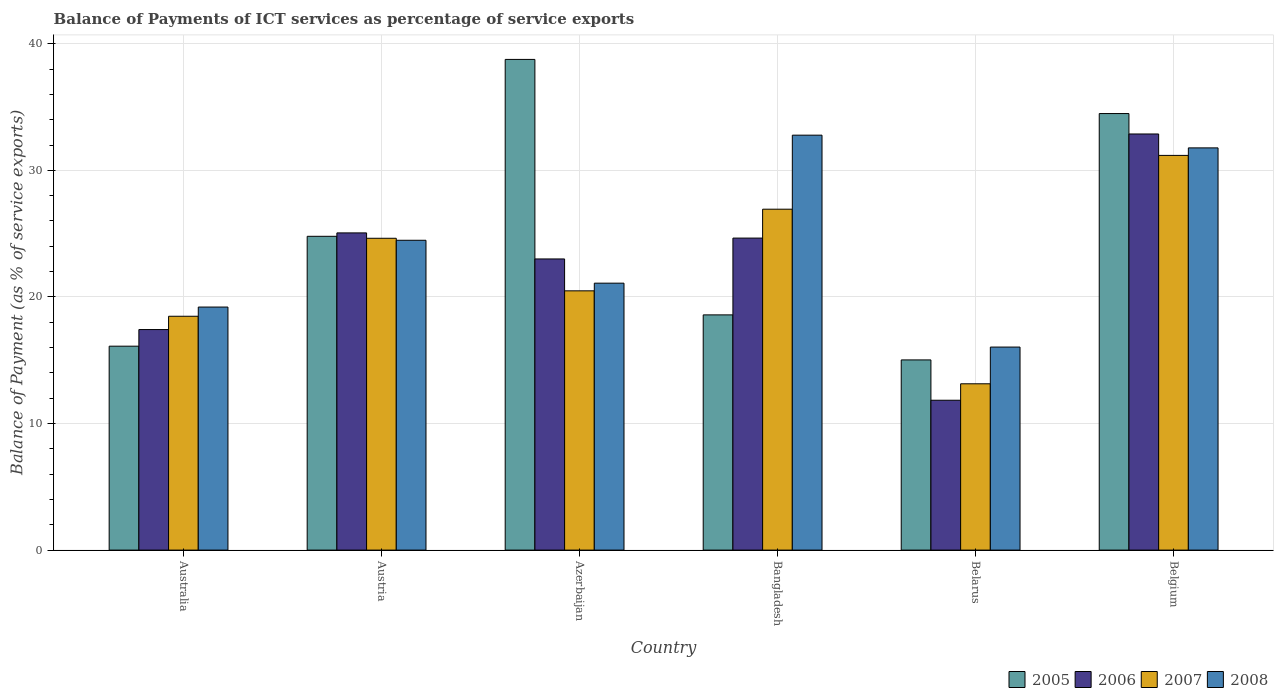Are the number of bars on each tick of the X-axis equal?
Ensure brevity in your answer.  Yes. How many bars are there on the 3rd tick from the left?
Make the answer very short. 4. What is the label of the 4th group of bars from the left?
Your response must be concise. Bangladesh. In how many cases, is the number of bars for a given country not equal to the number of legend labels?
Offer a terse response. 0. What is the balance of payments of ICT services in 2008 in Australia?
Give a very brief answer. 19.2. Across all countries, what is the maximum balance of payments of ICT services in 2008?
Provide a succinct answer. 32.78. Across all countries, what is the minimum balance of payments of ICT services in 2006?
Provide a short and direct response. 11.84. In which country was the balance of payments of ICT services in 2006 maximum?
Give a very brief answer. Belgium. In which country was the balance of payments of ICT services in 2008 minimum?
Ensure brevity in your answer.  Belarus. What is the total balance of payments of ICT services in 2006 in the graph?
Offer a terse response. 134.83. What is the difference between the balance of payments of ICT services in 2007 in Australia and that in Belarus?
Keep it short and to the point. 5.33. What is the difference between the balance of payments of ICT services in 2006 in Belgium and the balance of payments of ICT services in 2008 in Australia?
Ensure brevity in your answer.  13.67. What is the average balance of payments of ICT services in 2007 per country?
Ensure brevity in your answer.  22.47. What is the difference between the balance of payments of ICT services of/in 2008 and balance of payments of ICT services of/in 2005 in Australia?
Your response must be concise. 3.09. In how many countries, is the balance of payments of ICT services in 2008 greater than 16 %?
Make the answer very short. 6. What is the ratio of the balance of payments of ICT services in 2007 in Australia to that in Bangladesh?
Your answer should be very brief. 0.69. What is the difference between the highest and the second highest balance of payments of ICT services in 2006?
Offer a terse response. 7.81. What is the difference between the highest and the lowest balance of payments of ICT services in 2007?
Ensure brevity in your answer.  18.04. Is the sum of the balance of payments of ICT services in 2007 in Azerbaijan and Belarus greater than the maximum balance of payments of ICT services in 2005 across all countries?
Give a very brief answer. No. Is it the case that in every country, the sum of the balance of payments of ICT services in 2005 and balance of payments of ICT services in 2007 is greater than the sum of balance of payments of ICT services in 2008 and balance of payments of ICT services in 2006?
Offer a very short reply. No. What does the 1st bar from the left in Belarus represents?
Offer a very short reply. 2005. Is it the case that in every country, the sum of the balance of payments of ICT services in 2007 and balance of payments of ICT services in 2005 is greater than the balance of payments of ICT services in 2008?
Make the answer very short. Yes. How many bars are there?
Your response must be concise. 24. Are all the bars in the graph horizontal?
Make the answer very short. No. What is the difference between two consecutive major ticks on the Y-axis?
Offer a very short reply. 10. Are the values on the major ticks of Y-axis written in scientific E-notation?
Your response must be concise. No. Does the graph contain any zero values?
Ensure brevity in your answer.  No. Does the graph contain grids?
Keep it short and to the point. Yes. How many legend labels are there?
Offer a very short reply. 4. What is the title of the graph?
Your answer should be very brief. Balance of Payments of ICT services as percentage of service exports. What is the label or title of the Y-axis?
Your answer should be compact. Balance of Payment (as % of service exports). What is the Balance of Payment (as % of service exports) of 2005 in Australia?
Your answer should be very brief. 16.11. What is the Balance of Payment (as % of service exports) in 2006 in Australia?
Your answer should be compact. 17.42. What is the Balance of Payment (as % of service exports) in 2007 in Australia?
Offer a terse response. 18.47. What is the Balance of Payment (as % of service exports) of 2008 in Australia?
Give a very brief answer. 19.2. What is the Balance of Payment (as % of service exports) in 2005 in Austria?
Your response must be concise. 24.79. What is the Balance of Payment (as % of service exports) of 2006 in Austria?
Provide a succinct answer. 25.06. What is the Balance of Payment (as % of service exports) of 2007 in Austria?
Offer a terse response. 24.63. What is the Balance of Payment (as % of service exports) in 2008 in Austria?
Provide a succinct answer. 24.47. What is the Balance of Payment (as % of service exports) of 2005 in Azerbaijan?
Your response must be concise. 38.76. What is the Balance of Payment (as % of service exports) of 2006 in Azerbaijan?
Your answer should be compact. 23. What is the Balance of Payment (as % of service exports) in 2007 in Azerbaijan?
Your response must be concise. 20.48. What is the Balance of Payment (as % of service exports) of 2008 in Azerbaijan?
Give a very brief answer. 21.09. What is the Balance of Payment (as % of service exports) of 2005 in Bangladesh?
Make the answer very short. 18.58. What is the Balance of Payment (as % of service exports) in 2006 in Bangladesh?
Give a very brief answer. 24.65. What is the Balance of Payment (as % of service exports) of 2007 in Bangladesh?
Provide a short and direct response. 26.93. What is the Balance of Payment (as % of service exports) in 2008 in Bangladesh?
Make the answer very short. 32.78. What is the Balance of Payment (as % of service exports) of 2005 in Belarus?
Keep it short and to the point. 15.02. What is the Balance of Payment (as % of service exports) of 2006 in Belarus?
Offer a terse response. 11.84. What is the Balance of Payment (as % of service exports) of 2007 in Belarus?
Your answer should be compact. 13.14. What is the Balance of Payment (as % of service exports) of 2008 in Belarus?
Provide a succinct answer. 16.04. What is the Balance of Payment (as % of service exports) in 2005 in Belgium?
Provide a short and direct response. 34.48. What is the Balance of Payment (as % of service exports) of 2006 in Belgium?
Your response must be concise. 32.87. What is the Balance of Payment (as % of service exports) of 2007 in Belgium?
Offer a terse response. 31.18. What is the Balance of Payment (as % of service exports) in 2008 in Belgium?
Give a very brief answer. 31.77. Across all countries, what is the maximum Balance of Payment (as % of service exports) in 2005?
Make the answer very short. 38.76. Across all countries, what is the maximum Balance of Payment (as % of service exports) in 2006?
Your answer should be compact. 32.87. Across all countries, what is the maximum Balance of Payment (as % of service exports) in 2007?
Your response must be concise. 31.18. Across all countries, what is the maximum Balance of Payment (as % of service exports) in 2008?
Your answer should be very brief. 32.78. Across all countries, what is the minimum Balance of Payment (as % of service exports) of 2005?
Offer a terse response. 15.02. Across all countries, what is the minimum Balance of Payment (as % of service exports) of 2006?
Give a very brief answer. 11.84. Across all countries, what is the minimum Balance of Payment (as % of service exports) of 2007?
Offer a terse response. 13.14. Across all countries, what is the minimum Balance of Payment (as % of service exports) in 2008?
Keep it short and to the point. 16.04. What is the total Balance of Payment (as % of service exports) of 2005 in the graph?
Keep it short and to the point. 147.75. What is the total Balance of Payment (as % of service exports) in 2006 in the graph?
Provide a succinct answer. 134.83. What is the total Balance of Payment (as % of service exports) in 2007 in the graph?
Offer a terse response. 134.83. What is the total Balance of Payment (as % of service exports) in 2008 in the graph?
Give a very brief answer. 145.35. What is the difference between the Balance of Payment (as % of service exports) in 2005 in Australia and that in Austria?
Your answer should be compact. -8.68. What is the difference between the Balance of Payment (as % of service exports) in 2006 in Australia and that in Austria?
Make the answer very short. -7.63. What is the difference between the Balance of Payment (as % of service exports) of 2007 in Australia and that in Austria?
Give a very brief answer. -6.16. What is the difference between the Balance of Payment (as % of service exports) of 2008 in Australia and that in Austria?
Offer a very short reply. -5.28. What is the difference between the Balance of Payment (as % of service exports) in 2005 in Australia and that in Azerbaijan?
Your answer should be compact. -22.65. What is the difference between the Balance of Payment (as % of service exports) in 2006 in Australia and that in Azerbaijan?
Offer a very short reply. -5.58. What is the difference between the Balance of Payment (as % of service exports) of 2007 in Australia and that in Azerbaijan?
Offer a terse response. -2.01. What is the difference between the Balance of Payment (as % of service exports) in 2008 in Australia and that in Azerbaijan?
Ensure brevity in your answer.  -1.89. What is the difference between the Balance of Payment (as % of service exports) of 2005 in Australia and that in Bangladesh?
Provide a succinct answer. -2.47. What is the difference between the Balance of Payment (as % of service exports) in 2006 in Australia and that in Bangladesh?
Give a very brief answer. -7.22. What is the difference between the Balance of Payment (as % of service exports) in 2007 in Australia and that in Bangladesh?
Ensure brevity in your answer.  -8.46. What is the difference between the Balance of Payment (as % of service exports) of 2008 in Australia and that in Bangladesh?
Offer a terse response. -13.58. What is the difference between the Balance of Payment (as % of service exports) in 2005 in Australia and that in Belarus?
Ensure brevity in your answer.  1.08. What is the difference between the Balance of Payment (as % of service exports) in 2006 in Australia and that in Belarus?
Offer a very short reply. 5.58. What is the difference between the Balance of Payment (as % of service exports) of 2007 in Australia and that in Belarus?
Offer a terse response. 5.33. What is the difference between the Balance of Payment (as % of service exports) of 2008 in Australia and that in Belarus?
Provide a succinct answer. 3.16. What is the difference between the Balance of Payment (as % of service exports) of 2005 in Australia and that in Belgium?
Your response must be concise. -18.38. What is the difference between the Balance of Payment (as % of service exports) in 2006 in Australia and that in Belgium?
Your answer should be very brief. -15.45. What is the difference between the Balance of Payment (as % of service exports) in 2007 in Australia and that in Belgium?
Offer a very short reply. -12.71. What is the difference between the Balance of Payment (as % of service exports) of 2008 in Australia and that in Belgium?
Offer a terse response. -12.57. What is the difference between the Balance of Payment (as % of service exports) of 2005 in Austria and that in Azerbaijan?
Keep it short and to the point. -13.97. What is the difference between the Balance of Payment (as % of service exports) of 2006 in Austria and that in Azerbaijan?
Give a very brief answer. 2.06. What is the difference between the Balance of Payment (as % of service exports) of 2007 in Austria and that in Azerbaijan?
Offer a very short reply. 4.15. What is the difference between the Balance of Payment (as % of service exports) in 2008 in Austria and that in Azerbaijan?
Ensure brevity in your answer.  3.39. What is the difference between the Balance of Payment (as % of service exports) of 2005 in Austria and that in Bangladesh?
Provide a succinct answer. 6.21. What is the difference between the Balance of Payment (as % of service exports) of 2006 in Austria and that in Bangladesh?
Provide a succinct answer. 0.41. What is the difference between the Balance of Payment (as % of service exports) of 2007 in Austria and that in Bangladesh?
Provide a short and direct response. -2.3. What is the difference between the Balance of Payment (as % of service exports) in 2008 in Austria and that in Bangladesh?
Offer a terse response. -8.3. What is the difference between the Balance of Payment (as % of service exports) in 2005 in Austria and that in Belarus?
Keep it short and to the point. 9.76. What is the difference between the Balance of Payment (as % of service exports) of 2006 in Austria and that in Belarus?
Your response must be concise. 13.22. What is the difference between the Balance of Payment (as % of service exports) in 2007 in Austria and that in Belarus?
Your answer should be compact. 11.5. What is the difference between the Balance of Payment (as % of service exports) in 2008 in Austria and that in Belarus?
Your response must be concise. 8.44. What is the difference between the Balance of Payment (as % of service exports) of 2005 in Austria and that in Belgium?
Provide a short and direct response. -9.7. What is the difference between the Balance of Payment (as % of service exports) of 2006 in Austria and that in Belgium?
Offer a very short reply. -7.81. What is the difference between the Balance of Payment (as % of service exports) of 2007 in Austria and that in Belgium?
Give a very brief answer. -6.55. What is the difference between the Balance of Payment (as % of service exports) of 2008 in Austria and that in Belgium?
Your answer should be compact. -7.3. What is the difference between the Balance of Payment (as % of service exports) in 2005 in Azerbaijan and that in Bangladesh?
Your response must be concise. 20.18. What is the difference between the Balance of Payment (as % of service exports) of 2006 in Azerbaijan and that in Bangladesh?
Your response must be concise. -1.65. What is the difference between the Balance of Payment (as % of service exports) of 2007 in Azerbaijan and that in Bangladesh?
Keep it short and to the point. -6.45. What is the difference between the Balance of Payment (as % of service exports) of 2008 in Azerbaijan and that in Bangladesh?
Your answer should be compact. -11.69. What is the difference between the Balance of Payment (as % of service exports) in 2005 in Azerbaijan and that in Belarus?
Keep it short and to the point. 23.74. What is the difference between the Balance of Payment (as % of service exports) in 2006 in Azerbaijan and that in Belarus?
Offer a terse response. 11.16. What is the difference between the Balance of Payment (as % of service exports) in 2007 in Azerbaijan and that in Belarus?
Keep it short and to the point. 7.34. What is the difference between the Balance of Payment (as % of service exports) in 2008 in Azerbaijan and that in Belarus?
Keep it short and to the point. 5.05. What is the difference between the Balance of Payment (as % of service exports) in 2005 in Azerbaijan and that in Belgium?
Your response must be concise. 4.28. What is the difference between the Balance of Payment (as % of service exports) in 2006 in Azerbaijan and that in Belgium?
Offer a very short reply. -9.87. What is the difference between the Balance of Payment (as % of service exports) of 2007 in Azerbaijan and that in Belgium?
Your answer should be compact. -10.7. What is the difference between the Balance of Payment (as % of service exports) of 2008 in Azerbaijan and that in Belgium?
Keep it short and to the point. -10.69. What is the difference between the Balance of Payment (as % of service exports) of 2005 in Bangladesh and that in Belarus?
Your response must be concise. 3.56. What is the difference between the Balance of Payment (as % of service exports) of 2006 in Bangladesh and that in Belarus?
Provide a short and direct response. 12.81. What is the difference between the Balance of Payment (as % of service exports) of 2007 in Bangladesh and that in Belarus?
Offer a terse response. 13.79. What is the difference between the Balance of Payment (as % of service exports) of 2008 in Bangladesh and that in Belarus?
Ensure brevity in your answer.  16.74. What is the difference between the Balance of Payment (as % of service exports) of 2005 in Bangladesh and that in Belgium?
Ensure brevity in your answer.  -15.9. What is the difference between the Balance of Payment (as % of service exports) in 2006 in Bangladesh and that in Belgium?
Ensure brevity in your answer.  -8.22. What is the difference between the Balance of Payment (as % of service exports) of 2007 in Bangladesh and that in Belgium?
Keep it short and to the point. -4.25. What is the difference between the Balance of Payment (as % of service exports) in 2008 in Bangladesh and that in Belgium?
Your answer should be very brief. 1.01. What is the difference between the Balance of Payment (as % of service exports) in 2005 in Belarus and that in Belgium?
Offer a terse response. -19.46. What is the difference between the Balance of Payment (as % of service exports) in 2006 in Belarus and that in Belgium?
Offer a terse response. -21.03. What is the difference between the Balance of Payment (as % of service exports) of 2007 in Belarus and that in Belgium?
Make the answer very short. -18.04. What is the difference between the Balance of Payment (as % of service exports) in 2008 in Belarus and that in Belgium?
Your answer should be very brief. -15.73. What is the difference between the Balance of Payment (as % of service exports) of 2005 in Australia and the Balance of Payment (as % of service exports) of 2006 in Austria?
Make the answer very short. -8.95. What is the difference between the Balance of Payment (as % of service exports) of 2005 in Australia and the Balance of Payment (as % of service exports) of 2007 in Austria?
Give a very brief answer. -8.52. What is the difference between the Balance of Payment (as % of service exports) of 2005 in Australia and the Balance of Payment (as % of service exports) of 2008 in Austria?
Your response must be concise. -8.37. What is the difference between the Balance of Payment (as % of service exports) of 2006 in Australia and the Balance of Payment (as % of service exports) of 2007 in Austria?
Make the answer very short. -7.21. What is the difference between the Balance of Payment (as % of service exports) of 2006 in Australia and the Balance of Payment (as % of service exports) of 2008 in Austria?
Keep it short and to the point. -7.05. What is the difference between the Balance of Payment (as % of service exports) in 2007 in Australia and the Balance of Payment (as % of service exports) in 2008 in Austria?
Keep it short and to the point. -6. What is the difference between the Balance of Payment (as % of service exports) of 2005 in Australia and the Balance of Payment (as % of service exports) of 2006 in Azerbaijan?
Make the answer very short. -6.89. What is the difference between the Balance of Payment (as % of service exports) in 2005 in Australia and the Balance of Payment (as % of service exports) in 2007 in Azerbaijan?
Make the answer very short. -4.37. What is the difference between the Balance of Payment (as % of service exports) of 2005 in Australia and the Balance of Payment (as % of service exports) of 2008 in Azerbaijan?
Keep it short and to the point. -4.98. What is the difference between the Balance of Payment (as % of service exports) of 2006 in Australia and the Balance of Payment (as % of service exports) of 2007 in Azerbaijan?
Offer a very short reply. -3.06. What is the difference between the Balance of Payment (as % of service exports) of 2006 in Australia and the Balance of Payment (as % of service exports) of 2008 in Azerbaijan?
Ensure brevity in your answer.  -3.66. What is the difference between the Balance of Payment (as % of service exports) of 2007 in Australia and the Balance of Payment (as % of service exports) of 2008 in Azerbaijan?
Make the answer very short. -2.61. What is the difference between the Balance of Payment (as % of service exports) of 2005 in Australia and the Balance of Payment (as % of service exports) of 2006 in Bangladesh?
Your answer should be compact. -8.54. What is the difference between the Balance of Payment (as % of service exports) of 2005 in Australia and the Balance of Payment (as % of service exports) of 2007 in Bangladesh?
Offer a very short reply. -10.82. What is the difference between the Balance of Payment (as % of service exports) in 2005 in Australia and the Balance of Payment (as % of service exports) in 2008 in Bangladesh?
Provide a succinct answer. -16.67. What is the difference between the Balance of Payment (as % of service exports) of 2006 in Australia and the Balance of Payment (as % of service exports) of 2007 in Bangladesh?
Offer a terse response. -9.51. What is the difference between the Balance of Payment (as % of service exports) of 2006 in Australia and the Balance of Payment (as % of service exports) of 2008 in Bangladesh?
Give a very brief answer. -15.36. What is the difference between the Balance of Payment (as % of service exports) in 2007 in Australia and the Balance of Payment (as % of service exports) in 2008 in Bangladesh?
Give a very brief answer. -14.31. What is the difference between the Balance of Payment (as % of service exports) in 2005 in Australia and the Balance of Payment (as % of service exports) in 2006 in Belarus?
Your answer should be compact. 4.27. What is the difference between the Balance of Payment (as % of service exports) of 2005 in Australia and the Balance of Payment (as % of service exports) of 2007 in Belarus?
Give a very brief answer. 2.97. What is the difference between the Balance of Payment (as % of service exports) in 2005 in Australia and the Balance of Payment (as % of service exports) in 2008 in Belarus?
Keep it short and to the point. 0.07. What is the difference between the Balance of Payment (as % of service exports) in 2006 in Australia and the Balance of Payment (as % of service exports) in 2007 in Belarus?
Offer a very short reply. 4.28. What is the difference between the Balance of Payment (as % of service exports) of 2006 in Australia and the Balance of Payment (as % of service exports) of 2008 in Belarus?
Your answer should be compact. 1.38. What is the difference between the Balance of Payment (as % of service exports) of 2007 in Australia and the Balance of Payment (as % of service exports) of 2008 in Belarus?
Give a very brief answer. 2.43. What is the difference between the Balance of Payment (as % of service exports) in 2005 in Australia and the Balance of Payment (as % of service exports) in 2006 in Belgium?
Give a very brief answer. -16.76. What is the difference between the Balance of Payment (as % of service exports) of 2005 in Australia and the Balance of Payment (as % of service exports) of 2007 in Belgium?
Your response must be concise. -15.07. What is the difference between the Balance of Payment (as % of service exports) of 2005 in Australia and the Balance of Payment (as % of service exports) of 2008 in Belgium?
Ensure brevity in your answer.  -15.66. What is the difference between the Balance of Payment (as % of service exports) in 2006 in Australia and the Balance of Payment (as % of service exports) in 2007 in Belgium?
Ensure brevity in your answer.  -13.76. What is the difference between the Balance of Payment (as % of service exports) in 2006 in Australia and the Balance of Payment (as % of service exports) in 2008 in Belgium?
Give a very brief answer. -14.35. What is the difference between the Balance of Payment (as % of service exports) of 2007 in Australia and the Balance of Payment (as % of service exports) of 2008 in Belgium?
Offer a very short reply. -13.3. What is the difference between the Balance of Payment (as % of service exports) of 2005 in Austria and the Balance of Payment (as % of service exports) of 2006 in Azerbaijan?
Provide a succinct answer. 1.79. What is the difference between the Balance of Payment (as % of service exports) in 2005 in Austria and the Balance of Payment (as % of service exports) in 2007 in Azerbaijan?
Provide a short and direct response. 4.31. What is the difference between the Balance of Payment (as % of service exports) of 2005 in Austria and the Balance of Payment (as % of service exports) of 2008 in Azerbaijan?
Your answer should be very brief. 3.7. What is the difference between the Balance of Payment (as % of service exports) in 2006 in Austria and the Balance of Payment (as % of service exports) in 2007 in Azerbaijan?
Your answer should be compact. 4.58. What is the difference between the Balance of Payment (as % of service exports) in 2006 in Austria and the Balance of Payment (as % of service exports) in 2008 in Azerbaijan?
Make the answer very short. 3.97. What is the difference between the Balance of Payment (as % of service exports) of 2007 in Austria and the Balance of Payment (as % of service exports) of 2008 in Azerbaijan?
Your answer should be compact. 3.55. What is the difference between the Balance of Payment (as % of service exports) in 2005 in Austria and the Balance of Payment (as % of service exports) in 2006 in Bangladesh?
Your response must be concise. 0.14. What is the difference between the Balance of Payment (as % of service exports) in 2005 in Austria and the Balance of Payment (as % of service exports) in 2007 in Bangladesh?
Your answer should be compact. -2.14. What is the difference between the Balance of Payment (as % of service exports) in 2005 in Austria and the Balance of Payment (as % of service exports) in 2008 in Bangladesh?
Your answer should be compact. -7.99. What is the difference between the Balance of Payment (as % of service exports) of 2006 in Austria and the Balance of Payment (as % of service exports) of 2007 in Bangladesh?
Make the answer very short. -1.87. What is the difference between the Balance of Payment (as % of service exports) of 2006 in Austria and the Balance of Payment (as % of service exports) of 2008 in Bangladesh?
Make the answer very short. -7.72. What is the difference between the Balance of Payment (as % of service exports) in 2007 in Austria and the Balance of Payment (as % of service exports) in 2008 in Bangladesh?
Give a very brief answer. -8.14. What is the difference between the Balance of Payment (as % of service exports) in 2005 in Austria and the Balance of Payment (as % of service exports) in 2006 in Belarus?
Offer a very short reply. 12.95. What is the difference between the Balance of Payment (as % of service exports) of 2005 in Austria and the Balance of Payment (as % of service exports) of 2007 in Belarus?
Provide a short and direct response. 11.65. What is the difference between the Balance of Payment (as % of service exports) in 2005 in Austria and the Balance of Payment (as % of service exports) in 2008 in Belarus?
Provide a succinct answer. 8.75. What is the difference between the Balance of Payment (as % of service exports) in 2006 in Austria and the Balance of Payment (as % of service exports) in 2007 in Belarus?
Your answer should be very brief. 11.92. What is the difference between the Balance of Payment (as % of service exports) of 2006 in Austria and the Balance of Payment (as % of service exports) of 2008 in Belarus?
Your answer should be very brief. 9.02. What is the difference between the Balance of Payment (as % of service exports) of 2007 in Austria and the Balance of Payment (as % of service exports) of 2008 in Belarus?
Provide a short and direct response. 8.6. What is the difference between the Balance of Payment (as % of service exports) in 2005 in Austria and the Balance of Payment (as % of service exports) in 2006 in Belgium?
Ensure brevity in your answer.  -8.08. What is the difference between the Balance of Payment (as % of service exports) in 2005 in Austria and the Balance of Payment (as % of service exports) in 2007 in Belgium?
Your answer should be compact. -6.39. What is the difference between the Balance of Payment (as % of service exports) in 2005 in Austria and the Balance of Payment (as % of service exports) in 2008 in Belgium?
Ensure brevity in your answer.  -6.98. What is the difference between the Balance of Payment (as % of service exports) in 2006 in Austria and the Balance of Payment (as % of service exports) in 2007 in Belgium?
Provide a short and direct response. -6.12. What is the difference between the Balance of Payment (as % of service exports) of 2006 in Austria and the Balance of Payment (as % of service exports) of 2008 in Belgium?
Provide a succinct answer. -6.72. What is the difference between the Balance of Payment (as % of service exports) of 2007 in Austria and the Balance of Payment (as % of service exports) of 2008 in Belgium?
Give a very brief answer. -7.14. What is the difference between the Balance of Payment (as % of service exports) in 2005 in Azerbaijan and the Balance of Payment (as % of service exports) in 2006 in Bangladesh?
Offer a terse response. 14.12. What is the difference between the Balance of Payment (as % of service exports) of 2005 in Azerbaijan and the Balance of Payment (as % of service exports) of 2007 in Bangladesh?
Give a very brief answer. 11.83. What is the difference between the Balance of Payment (as % of service exports) of 2005 in Azerbaijan and the Balance of Payment (as % of service exports) of 2008 in Bangladesh?
Offer a very short reply. 5.98. What is the difference between the Balance of Payment (as % of service exports) in 2006 in Azerbaijan and the Balance of Payment (as % of service exports) in 2007 in Bangladesh?
Ensure brevity in your answer.  -3.93. What is the difference between the Balance of Payment (as % of service exports) of 2006 in Azerbaijan and the Balance of Payment (as % of service exports) of 2008 in Bangladesh?
Keep it short and to the point. -9.78. What is the difference between the Balance of Payment (as % of service exports) of 2007 in Azerbaijan and the Balance of Payment (as % of service exports) of 2008 in Bangladesh?
Ensure brevity in your answer.  -12.3. What is the difference between the Balance of Payment (as % of service exports) in 2005 in Azerbaijan and the Balance of Payment (as % of service exports) in 2006 in Belarus?
Keep it short and to the point. 26.92. What is the difference between the Balance of Payment (as % of service exports) in 2005 in Azerbaijan and the Balance of Payment (as % of service exports) in 2007 in Belarus?
Provide a short and direct response. 25.62. What is the difference between the Balance of Payment (as % of service exports) in 2005 in Azerbaijan and the Balance of Payment (as % of service exports) in 2008 in Belarus?
Keep it short and to the point. 22.72. What is the difference between the Balance of Payment (as % of service exports) in 2006 in Azerbaijan and the Balance of Payment (as % of service exports) in 2007 in Belarus?
Ensure brevity in your answer.  9.86. What is the difference between the Balance of Payment (as % of service exports) in 2006 in Azerbaijan and the Balance of Payment (as % of service exports) in 2008 in Belarus?
Your answer should be compact. 6.96. What is the difference between the Balance of Payment (as % of service exports) of 2007 in Azerbaijan and the Balance of Payment (as % of service exports) of 2008 in Belarus?
Provide a succinct answer. 4.44. What is the difference between the Balance of Payment (as % of service exports) of 2005 in Azerbaijan and the Balance of Payment (as % of service exports) of 2006 in Belgium?
Ensure brevity in your answer.  5.89. What is the difference between the Balance of Payment (as % of service exports) of 2005 in Azerbaijan and the Balance of Payment (as % of service exports) of 2007 in Belgium?
Your answer should be compact. 7.58. What is the difference between the Balance of Payment (as % of service exports) of 2005 in Azerbaijan and the Balance of Payment (as % of service exports) of 2008 in Belgium?
Your answer should be compact. 6.99. What is the difference between the Balance of Payment (as % of service exports) in 2006 in Azerbaijan and the Balance of Payment (as % of service exports) in 2007 in Belgium?
Ensure brevity in your answer.  -8.18. What is the difference between the Balance of Payment (as % of service exports) of 2006 in Azerbaijan and the Balance of Payment (as % of service exports) of 2008 in Belgium?
Your answer should be very brief. -8.77. What is the difference between the Balance of Payment (as % of service exports) of 2007 in Azerbaijan and the Balance of Payment (as % of service exports) of 2008 in Belgium?
Ensure brevity in your answer.  -11.29. What is the difference between the Balance of Payment (as % of service exports) in 2005 in Bangladesh and the Balance of Payment (as % of service exports) in 2006 in Belarus?
Provide a short and direct response. 6.74. What is the difference between the Balance of Payment (as % of service exports) in 2005 in Bangladesh and the Balance of Payment (as % of service exports) in 2007 in Belarus?
Keep it short and to the point. 5.44. What is the difference between the Balance of Payment (as % of service exports) in 2005 in Bangladesh and the Balance of Payment (as % of service exports) in 2008 in Belarus?
Your answer should be very brief. 2.54. What is the difference between the Balance of Payment (as % of service exports) of 2006 in Bangladesh and the Balance of Payment (as % of service exports) of 2007 in Belarus?
Ensure brevity in your answer.  11.51. What is the difference between the Balance of Payment (as % of service exports) of 2006 in Bangladesh and the Balance of Payment (as % of service exports) of 2008 in Belarus?
Provide a short and direct response. 8.61. What is the difference between the Balance of Payment (as % of service exports) in 2007 in Bangladesh and the Balance of Payment (as % of service exports) in 2008 in Belarus?
Offer a terse response. 10.89. What is the difference between the Balance of Payment (as % of service exports) in 2005 in Bangladesh and the Balance of Payment (as % of service exports) in 2006 in Belgium?
Provide a succinct answer. -14.29. What is the difference between the Balance of Payment (as % of service exports) of 2005 in Bangladesh and the Balance of Payment (as % of service exports) of 2007 in Belgium?
Your response must be concise. -12.6. What is the difference between the Balance of Payment (as % of service exports) in 2005 in Bangladesh and the Balance of Payment (as % of service exports) in 2008 in Belgium?
Give a very brief answer. -13.19. What is the difference between the Balance of Payment (as % of service exports) of 2006 in Bangladesh and the Balance of Payment (as % of service exports) of 2007 in Belgium?
Ensure brevity in your answer.  -6.53. What is the difference between the Balance of Payment (as % of service exports) in 2006 in Bangladesh and the Balance of Payment (as % of service exports) in 2008 in Belgium?
Offer a very short reply. -7.13. What is the difference between the Balance of Payment (as % of service exports) of 2007 in Bangladesh and the Balance of Payment (as % of service exports) of 2008 in Belgium?
Make the answer very short. -4.84. What is the difference between the Balance of Payment (as % of service exports) of 2005 in Belarus and the Balance of Payment (as % of service exports) of 2006 in Belgium?
Give a very brief answer. -17.85. What is the difference between the Balance of Payment (as % of service exports) in 2005 in Belarus and the Balance of Payment (as % of service exports) in 2007 in Belgium?
Your answer should be compact. -16.16. What is the difference between the Balance of Payment (as % of service exports) in 2005 in Belarus and the Balance of Payment (as % of service exports) in 2008 in Belgium?
Keep it short and to the point. -16.75. What is the difference between the Balance of Payment (as % of service exports) of 2006 in Belarus and the Balance of Payment (as % of service exports) of 2007 in Belgium?
Give a very brief answer. -19.34. What is the difference between the Balance of Payment (as % of service exports) in 2006 in Belarus and the Balance of Payment (as % of service exports) in 2008 in Belgium?
Ensure brevity in your answer.  -19.93. What is the difference between the Balance of Payment (as % of service exports) of 2007 in Belarus and the Balance of Payment (as % of service exports) of 2008 in Belgium?
Make the answer very short. -18.64. What is the average Balance of Payment (as % of service exports) in 2005 per country?
Make the answer very short. 24.62. What is the average Balance of Payment (as % of service exports) of 2006 per country?
Give a very brief answer. 22.47. What is the average Balance of Payment (as % of service exports) of 2007 per country?
Offer a terse response. 22.47. What is the average Balance of Payment (as % of service exports) of 2008 per country?
Make the answer very short. 24.22. What is the difference between the Balance of Payment (as % of service exports) of 2005 and Balance of Payment (as % of service exports) of 2006 in Australia?
Your answer should be compact. -1.31. What is the difference between the Balance of Payment (as % of service exports) in 2005 and Balance of Payment (as % of service exports) in 2007 in Australia?
Give a very brief answer. -2.36. What is the difference between the Balance of Payment (as % of service exports) in 2005 and Balance of Payment (as % of service exports) in 2008 in Australia?
Offer a terse response. -3.09. What is the difference between the Balance of Payment (as % of service exports) in 2006 and Balance of Payment (as % of service exports) in 2007 in Australia?
Provide a short and direct response. -1.05. What is the difference between the Balance of Payment (as % of service exports) of 2006 and Balance of Payment (as % of service exports) of 2008 in Australia?
Your answer should be very brief. -1.78. What is the difference between the Balance of Payment (as % of service exports) of 2007 and Balance of Payment (as % of service exports) of 2008 in Australia?
Give a very brief answer. -0.73. What is the difference between the Balance of Payment (as % of service exports) in 2005 and Balance of Payment (as % of service exports) in 2006 in Austria?
Provide a short and direct response. -0.27. What is the difference between the Balance of Payment (as % of service exports) in 2005 and Balance of Payment (as % of service exports) in 2007 in Austria?
Your response must be concise. 0.16. What is the difference between the Balance of Payment (as % of service exports) of 2005 and Balance of Payment (as % of service exports) of 2008 in Austria?
Offer a very short reply. 0.31. What is the difference between the Balance of Payment (as % of service exports) of 2006 and Balance of Payment (as % of service exports) of 2007 in Austria?
Ensure brevity in your answer.  0.42. What is the difference between the Balance of Payment (as % of service exports) of 2006 and Balance of Payment (as % of service exports) of 2008 in Austria?
Ensure brevity in your answer.  0.58. What is the difference between the Balance of Payment (as % of service exports) of 2007 and Balance of Payment (as % of service exports) of 2008 in Austria?
Offer a terse response. 0.16. What is the difference between the Balance of Payment (as % of service exports) of 2005 and Balance of Payment (as % of service exports) of 2006 in Azerbaijan?
Make the answer very short. 15.76. What is the difference between the Balance of Payment (as % of service exports) of 2005 and Balance of Payment (as % of service exports) of 2007 in Azerbaijan?
Make the answer very short. 18.28. What is the difference between the Balance of Payment (as % of service exports) of 2005 and Balance of Payment (as % of service exports) of 2008 in Azerbaijan?
Your response must be concise. 17.68. What is the difference between the Balance of Payment (as % of service exports) of 2006 and Balance of Payment (as % of service exports) of 2007 in Azerbaijan?
Your answer should be very brief. 2.52. What is the difference between the Balance of Payment (as % of service exports) of 2006 and Balance of Payment (as % of service exports) of 2008 in Azerbaijan?
Provide a short and direct response. 1.91. What is the difference between the Balance of Payment (as % of service exports) of 2007 and Balance of Payment (as % of service exports) of 2008 in Azerbaijan?
Provide a succinct answer. -0.61. What is the difference between the Balance of Payment (as % of service exports) of 2005 and Balance of Payment (as % of service exports) of 2006 in Bangladesh?
Ensure brevity in your answer.  -6.07. What is the difference between the Balance of Payment (as % of service exports) in 2005 and Balance of Payment (as % of service exports) in 2007 in Bangladesh?
Provide a succinct answer. -8.35. What is the difference between the Balance of Payment (as % of service exports) of 2005 and Balance of Payment (as % of service exports) of 2008 in Bangladesh?
Offer a terse response. -14.2. What is the difference between the Balance of Payment (as % of service exports) in 2006 and Balance of Payment (as % of service exports) in 2007 in Bangladesh?
Give a very brief answer. -2.28. What is the difference between the Balance of Payment (as % of service exports) of 2006 and Balance of Payment (as % of service exports) of 2008 in Bangladesh?
Your response must be concise. -8.13. What is the difference between the Balance of Payment (as % of service exports) in 2007 and Balance of Payment (as % of service exports) in 2008 in Bangladesh?
Your answer should be very brief. -5.85. What is the difference between the Balance of Payment (as % of service exports) of 2005 and Balance of Payment (as % of service exports) of 2006 in Belarus?
Your answer should be compact. 3.19. What is the difference between the Balance of Payment (as % of service exports) of 2005 and Balance of Payment (as % of service exports) of 2007 in Belarus?
Your response must be concise. 1.89. What is the difference between the Balance of Payment (as % of service exports) in 2005 and Balance of Payment (as % of service exports) in 2008 in Belarus?
Keep it short and to the point. -1.01. What is the difference between the Balance of Payment (as % of service exports) in 2006 and Balance of Payment (as % of service exports) in 2007 in Belarus?
Your response must be concise. -1.3. What is the difference between the Balance of Payment (as % of service exports) in 2006 and Balance of Payment (as % of service exports) in 2008 in Belarus?
Offer a very short reply. -4.2. What is the difference between the Balance of Payment (as % of service exports) of 2007 and Balance of Payment (as % of service exports) of 2008 in Belarus?
Offer a very short reply. -2.9. What is the difference between the Balance of Payment (as % of service exports) of 2005 and Balance of Payment (as % of service exports) of 2006 in Belgium?
Provide a succinct answer. 1.61. What is the difference between the Balance of Payment (as % of service exports) of 2005 and Balance of Payment (as % of service exports) of 2007 in Belgium?
Give a very brief answer. 3.31. What is the difference between the Balance of Payment (as % of service exports) of 2005 and Balance of Payment (as % of service exports) of 2008 in Belgium?
Make the answer very short. 2.71. What is the difference between the Balance of Payment (as % of service exports) of 2006 and Balance of Payment (as % of service exports) of 2007 in Belgium?
Provide a short and direct response. 1.69. What is the difference between the Balance of Payment (as % of service exports) in 2006 and Balance of Payment (as % of service exports) in 2008 in Belgium?
Ensure brevity in your answer.  1.1. What is the difference between the Balance of Payment (as % of service exports) of 2007 and Balance of Payment (as % of service exports) of 2008 in Belgium?
Offer a very short reply. -0.59. What is the ratio of the Balance of Payment (as % of service exports) in 2005 in Australia to that in Austria?
Offer a terse response. 0.65. What is the ratio of the Balance of Payment (as % of service exports) of 2006 in Australia to that in Austria?
Your answer should be very brief. 0.7. What is the ratio of the Balance of Payment (as % of service exports) in 2007 in Australia to that in Austria?
Your answer should be compact. 0.75. What is the ratio of the Balance of Payment (as % of service exports) in 2008 in Australia to that in Austria?
Your response must be concise. 0.78. What is the ratio of the Balance of Payment (as % of service exports) of 2005 in Australia to that in Azerbaijan?
Offer a terse response. 0.42. What is the ratio of the Balance of Payment (as % of service exports) of 2006 in Australia to that in Azerbaijan?
Provide a succinct answer. 0.76. What is the ratio of the Balance of Payment (as % of service exports) of 2007 in Australia to that in Azerbaijan?
Give a very brief answer. 0.9. What is the ratio of the Balance of Payment (as % of service exports) in 2008 in Australia to that in Azerbaijan?
Ensure brevity in your answer.  0.91. What is the ratio of the Balance of Payment (as % of service exports) in 2005 in Australia to that in Bangladesh?
Your response must be concise. 0.87. What is the ratio of the Balance of Payment (as % of service exports) of 2006 in Australia to that in Bangladesh?
Your response must be concise. 0.71. What is the ratio of the Balance of Payment (as % of service exports) in 2007 in Australia to that in Bangladesh?
Give a very brief answer. 0.69. What is the ratio of the Balance of Payment (as % of service exports) of 2008 in Australia to that in Bangladesh?
Your answer should be compact. 0.59. What is the ratio of the Balance of Payment (as % of service exports) of 2005 in Australia to that in Belarus?
Your answer should be very brief. 1.07. What is the ratio of the Balance of Payment (as % of service exports) in 2006 in Australia to that in Belarus?
Keep it short and to the point. 1.47. What is the ratio of the Balance of Payment (as % of service exports) in 2007 in Australia to that in Belarus?
Offer a terse response. 1.41. What is the ratio of the Balance of Payment (as % of service exports) of 2008 in Australia to that in Belarus?
Make the answer very short. 1.2. What is the ratio of the Balance of Payment (as % of service exports) in 2005 in Australia to that in Belgium?
Your answer should be compact. 0.47. What is the ratio of the Balance of Payment (as % of service exports) in 2006 in Australia to that in Belgium?
Keep it short and to the point. 0.53. What is the ratio of the Balance of Payment (as % of service exports) of 2007 in Australia to that in Belgium?
Give a very brief answer. 0.59. What is the ratio of the Balance of Payment (as % of service exports) in 2008 in Australia to that in Belgium?
Keep it short and to the point. 0.6. What is the ratio of the Balance of Payment (as % of service exports) of 2005 in Austria to that in Azerbaijan?
Ensure brevity in your answer.  0.64. What is the ratio of the Balance of Payment (as % of service exports) in 2006 in Austria to that in Azerbaijan?
Keep it short and to the point. 1.09. What is the ratio of the Balance of Payment (as % of service exports) of 2007 in Austria to that in Azerbaijan?
Offer a terse response. 1.2. What is the ratio of the Balance of Payment (as % of service exports) in 2008 in Austria to that in Azerbaijan?
Give a very brief answer. 1.16. What is the ratio of the Balance of Payment (as % of service exports) in 2005 in Austria to that in Bangladesh?
Your response must be concise. 1.33. What is the ratio of the Balance of Payment (as % of service exports) of 2006 in Austria to that in Bangladesh?
Your response must be concise. 1.02. What is the ratio of the Balance of Payment (as % of service exports) of 2007 in Austria to that in Bangladesh?
Your response must be concise. 0.91. What is the ratio of the Balance of Payment (as % of service exports) in 2008 in Austria to that in Bangladesh?
Your answer should be very brief. 0.75. What is the ratio of the Balance of Payment (as % of service exports) in 2005 in Austria to that in Belarus?
Provide a succinct answer. 1.65. What is the ratio of the Balance of Payment (as % of service exports) in 2006 in Austria to that in Belarus?
Offer a terse response. 2.12. What is the ratio of the Balance of Payment (as % of service exports) of 2007 in Austria to that in Belarus?
Keep it short and to the point. 1.88. What is the ratio of the Balance of Payment (as % of service exports) of 2008 in Austria to that in Belarus?
Offer a terse response. 1.53. What is the ratio of the Balance of Payment (as % of service exports) of 2005 in Austria to that in Belgium?
Your answer should be compact. 0.72. What is the ratio of the Balance of Payment (as % of service exports) of 2006 in Austria to that in Belgium?
Give a very brief answer. 0.76. What is the ratio of the Balance of Payment (as % of service exports) of 2007 in Austria to that in Belgium?
Keep it short and to the point. 0.79. What is the ratio of the Balance of Payment (as % of service exports) in 2008 in Austria to that in Belgium?
Provide a short and direct response. 0.77. What is the ratio of the Balance of Payment (as % of service exports) in 2005 in Azerbaijan to that in Bangladesh?
Your response must be concise. 2.09. What is the ratio of the Balance of Payment (as % of service exports) of 2006 in Azerbaijan to that in Bangladesh?
Ensure brevity in your answer.  0.93. What is the ratio of the Balance of Payment (as % of service exports) of 2007 in Azerbaijan to that in Bangladesh?
Give a very brief answer. 0.76. What is the ratio of the Balance of Payment (as % of service exports) in 2008 in Azerbaijan to that in Bangladesh?
Provide a short and direct response. 0.64. What is the ratio of the Balance of Payment (as % of service exports) of 2005 in Azerbaijan to that in Belarus?
Keep it short and to the point. 2.58. What is the ratio of the Balance of Payment (as % of service exports) of 2006 in Azerbaijan to that in Belarus?
Your answer should be compact. 1.94. What is the ratio of the Balance of Payment (as % of service exports) in 2007 in Azerbaijan to that in Belarus?
Offer a very short reply. 1.56. What is the ratio of the Balance of Payment (as % of service exports) in 2008 in Azerbaijan to that in Belarus?
Offer a terse response. 1.31. What is the ratio of the Balance of Payment (as % of service exports) of 2005 in Azerbaijan to that in Belgium?
Keep it short and to the point. 1.12. What is the ratio of the Balance of Payment (as % of service exports) of 2006 in Azerbaijan to that in Belgium?
Give a very brief answer. 0.7. What is the ratio of the Balance of Payment (as % of service exports) in 2007 in Azerbaijan to that in Belgium?
Your response must be concise. 0.66. What is the ratio of the Balance of Payment (as % of service exports) of 2008 in Azerbaijan to that in Belgium?
Offer a very short reply. 0.66. What is the ratio of the Balance of Payment (as % of service exports) in 2005 in Bangladesh to that in Belarus?
Keep it short and to the point. 1.24. What is the ratio of the Balance of Payment (as % of service exports) of 2006 in Bangladesh to that in Belarus?
Your response must be concise. 2.08. What is the ratio of the Balance of Payment (as % of service exports) in 2007 in Bangladesh to that in Belarus?
Give a very brief answer. 2.05. What is the ratio of the Balance of Payment (as % of service exports) of 2008 in Bangladesh to that in Belarus?
Ensure brevity in your answer.  2.04. What is the ratio of the Balance of Payment (as % of service exports) of 2005 in Bangladesh to that in Belgium?
Make the answer very short. 0.54. What is the ratio of the Balance of Payment (as % of service exports) in 2006 in Bangladesh to that in Belgium?
Give a very brief answer. 0.75. What is the ratio of the Balance of Payment (as % of service exports) of 2007 in Bangladesh to that in Belgium?
Provide a succinct answer. 0.86. What is the ratio of the Balance of Payment (as % of service exports) of 2008 in Bangladesh to that in Belgium?
Provide a short and direct response. 1.03. What is the ratio of the Balance of Payment (as % of service exports) of 2005 in Belarus to that in Belgium?
Your response must be concise. 0.44. What is the ratio of the Balance of Payment (as % of service exports) of 2006 in Belarus to that in Belgium?
Your answer should be compact. 0.36. What is the ratio of the Balance of Payment (as % of service exports) of 2007 in Belarus to that in Belgium?
Provide a short and direct response. 0.42. What is the ratio of the Balance of Payment (as % of service exports) of 2008 in Belarus to that in Belgium?
Provide a short and direct response. 0.5. What is the difference between the highest and the second highest Balance of Payment (as % of service exports) in 2005?
Provide a succinct answer. 4.28. What is the difference between the highest and the second highest Balance of Payment (as % of service exports) of 2006?
Your answer should be very brief. 7.81. What is the difference between the highest and the second highest Balance of Payment (as % of service exports) in 2007?
Your answer should be compact. 4.25. What is the difference between the highest and the lowest Balance of Payment (as % of service exports) of 2005?
Your answer should be compact. 23.74. What is the difference between the highest and the lowest Balance of Payment (as % of service exports) in 2006?
Provide a succinct answer. 21.03. What is the difference between the highest and the lowest Balance of Payment (as % of service exports) of 2007?
Provide a succinct answer. 18.04. What is the difference between the highest and the lowest Balance of Payment (as % of service exports) in 2008?
Your answer should be very brief. 16.74. 